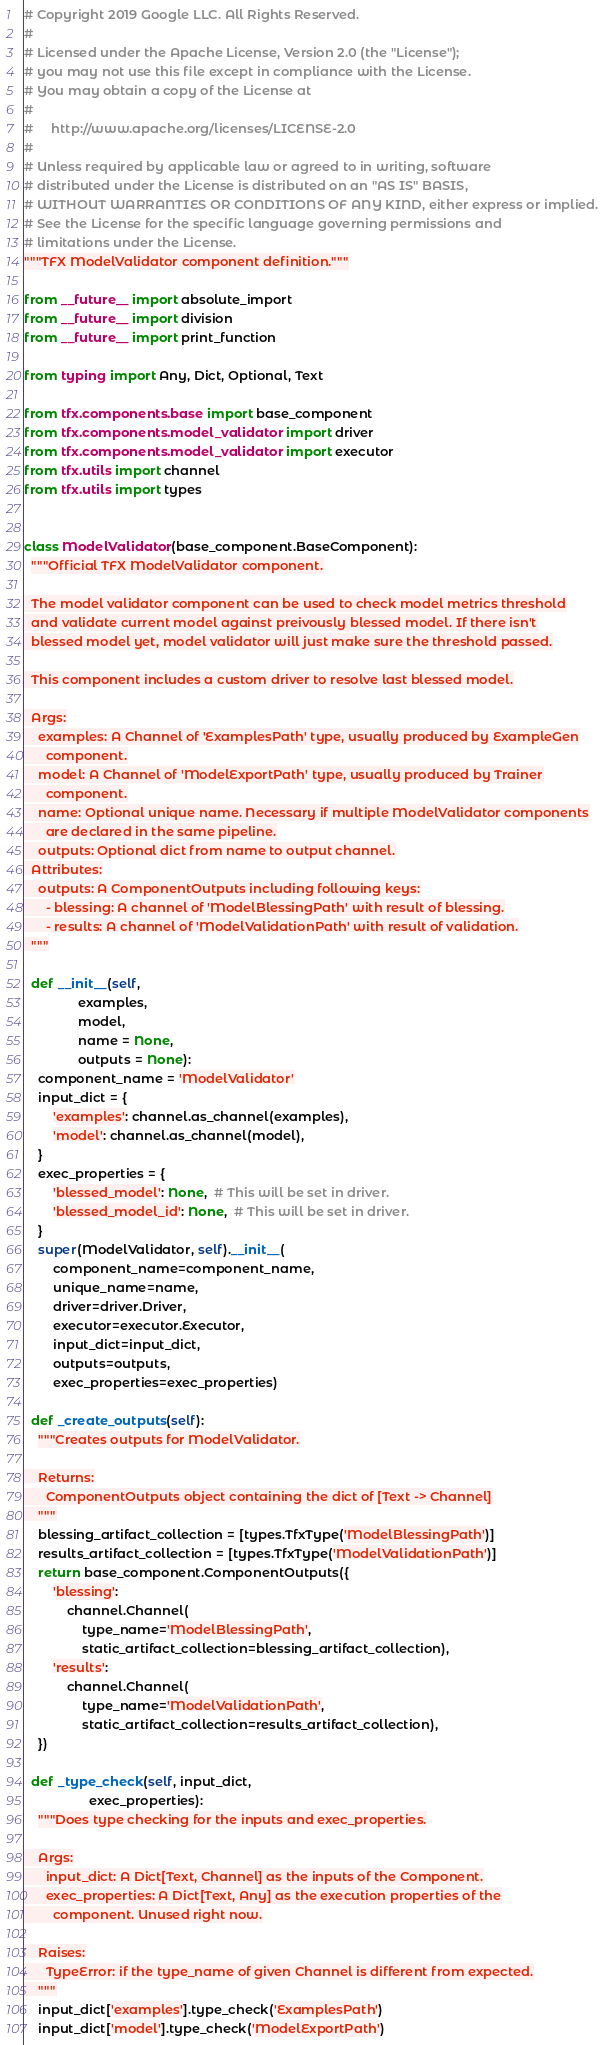Convert code to text. <code><loc_0><loc_0><loc_500><loc_500><_Python_># Copyright 2019 Google LLC. All Rights Reserved.
#
# Licensed under the Apache License, Version 2.0 (the "License");
# you may not use this file except in compliance with the License.
# You may obtain a copy of the License at
#
#     http://www.apache.org/licenses/LICENSE-2.0
#
# Unless required by applicable law or agreed to in writing, software
# distributed under the License is distributed on an "AS IS" BASIS,
# WITHOUT WARRANTIES OR CONDITIONS OF ANY KIND, either express or implied.
# See the License for the specific language governing permissions and
# limitations under the License.
"""TFX ModelValidator component definition."""

from __future__ import absolute_import
from __future__ import division
from __future__ import print_function

from typing import Any, Dict, Optional, Text

from tfx.components.base import base_component
from tfx.components.model_validator import driver
from tfx.components.model_validator import executor
from tfx.utils import channel
from tfx.utils import types


class ModelValidator(base_component.BaseComponent):
  """Official TFX ModelValidator component.

  The model validator component can be used to check model metrics threshold
  and validate current model against preivously blessed model. If there isn't
  blessed model yet, model validator will just make sure the threshold passed.

  This component includes a custom driver to resolve last blessed model.

  Args:
    examples: A Channel of 'ExamplesPath' type, usually produced by ExampleGen
      component.
    model: A Channel of 'ModelExportPath' type, usually produced by Trainer
      component.
    name: Optional unique name. Necessary if multiple ModelValidator components
      are declared in the same pipeline.
    outputs: Optional dict from name to output channel.
  Attributes:
    outputs: A ComponentOutputs including following keys:
      - blessing: A channel of 'ModelBlessingPath' with result of blessing.
      - results: A channel of 'ModelValidationPath' with result of validation.
  """

  def __init__(self,
               examples,
               model,
               name = None,
               outputs = None):
    component_name = 'ModelValidator'
    input_dict = {
        'examples': channel.as_channel(examples),
        'model': channel.as_channel(model),
    }
    exec_properties = {
        'blessed_model': None,  # This will be set in driver.
        'blessed_model_id': None,  # This will be set in driver.
    }
    super(ModelValidator, self).__init__(
        component_name=component_name,
        unique_name=name,
        driver=driver.Driver,
        executor=executor.Executor,
        input_dict=input_dict,
        outputs=outputs,
        exec_properties=exec_properties)

  def _create_outputs(self):
    """Creates outputs for ModelValidator.

    Returns:
      ComponentOutputs object containing the dict of [Text -> Channel]
    """
    blessing_artifact_collection = [types.TfxType('ModelBlessingPath')]
    results_artifact_collection = [types.TfxType('ModelValidationPath')]
    return base_component.ComponentOutputs({
        'blessing':
            channel.Channel(
                type_name='ModelBlessingPath',
                static_artifact_collection=blessing_artifact_collection),
        'results':
            channel.Channel(
                type_name='ModelValidationPath',
                static_artifact_collection=results_artifact_collection),
    })

  def _type_check(self, input_dict,
                  exec_properties):
    """Does type checking for the inputs and exec_properties.

    Args:
      input_dict: A Dict[Text, Channel] as the inputs of the Component.
      exec_properties: A Dict[Text, Any] as the execution properties of the
        component. Unused right now.

    Raises:
      TypeError: if the type_name of given Channel is different from expected.
    """
    input_dict['examples'].type_check('ExamplesPath')
    input_dict['model'].type_check('ModelExportPath')
</code> 